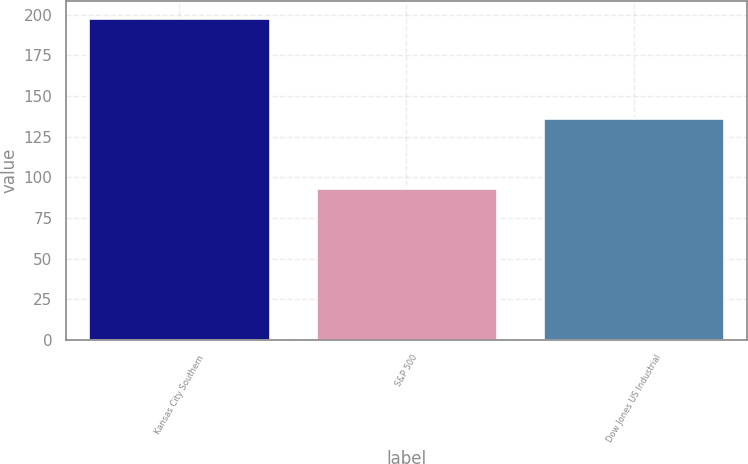<chart> <loc_0><loc_0><loc_500><loc_500><bar_chart><fcel>Kansas City Southern<fcel>S&P 500<fcel>Dow Jones US Industrial<nl><fcel>198.11<fcel>93.61<fcel>136.47<nl></chart> 